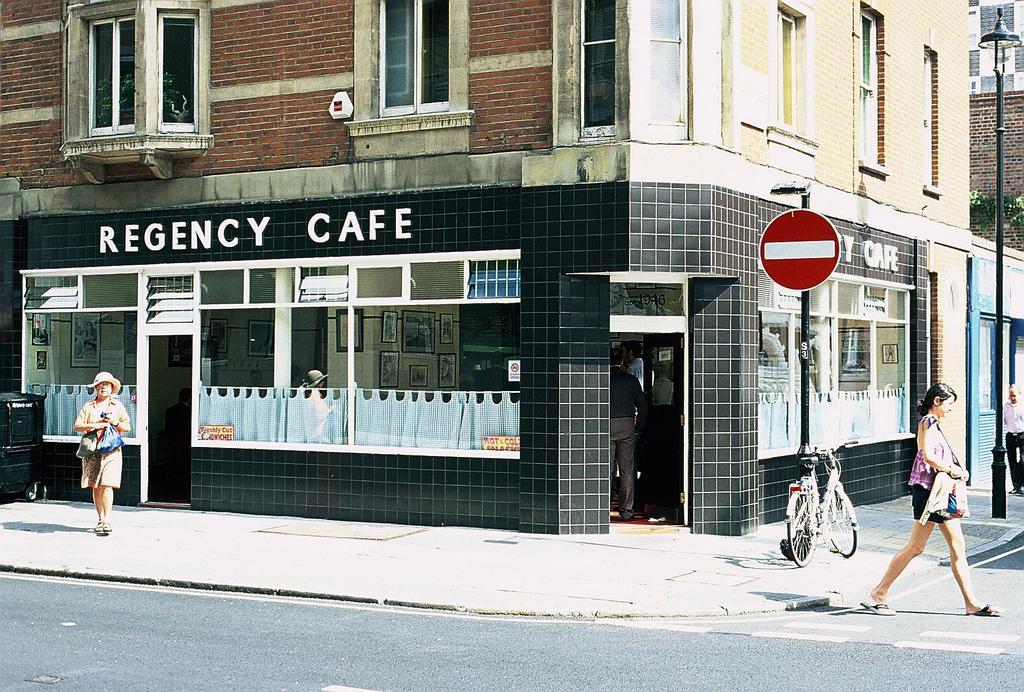Please provide a concise description of this image. In this image I can see the road. On the road I can see one person walking. To the side of the road there are poles and I can see two people with different color dressers. I can also see the bicycle to the side. In the background there is a building with windows. And I can also see the name regency cafe is written on the building. 